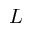<formula> <loc_0><loc_0><loc_500><loc_500>L</formula> 